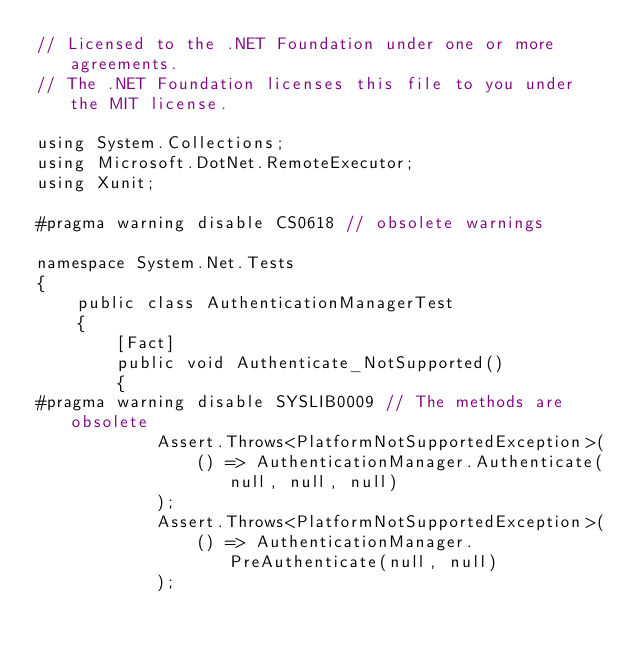Convert code to text. <code><loc_0><loc_0><loc_500><loc_500><_C#_>// Licensed to the .NET Foundation under one or more agreements.
// The .NET Foundation licenses this file to you under the MIT license.

using System.Collections;
using Microsoft.DotNet.RemoteExecutor;
using Xunit;

#pragma warning disable CS0618 // obsolete warnings

namespace System.Net.Tests
{
    public class AuthenticationManagerTest
    {
        [Fact]
        public void Authenticate_NotSupported()
        {
#pragma warning disable SYSLIB0009 // The methods are obsolete
            Assert.Throws<PlatformNotSupportedException>(
                () => AuthenticationManager.Authenticate(null, null, null)
            );
            Assert.Throws<PlatformNotSupportedException>(
                () => AuthenticationManager.PreAuthenticate(null, null)
            );</code> 